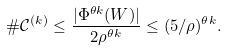Convert formula to latex. <formula><loc_0><loc_0><loc_500><loc_500>\# \mathcal { C } ^ { ( k ) } \leq \frac { | \Phi ^ { \theta k } ( W ) | } { 2 \rho ^ { \theta k } } \leq ( 5 / \rho ) ^ { \theta k } .</formula> 